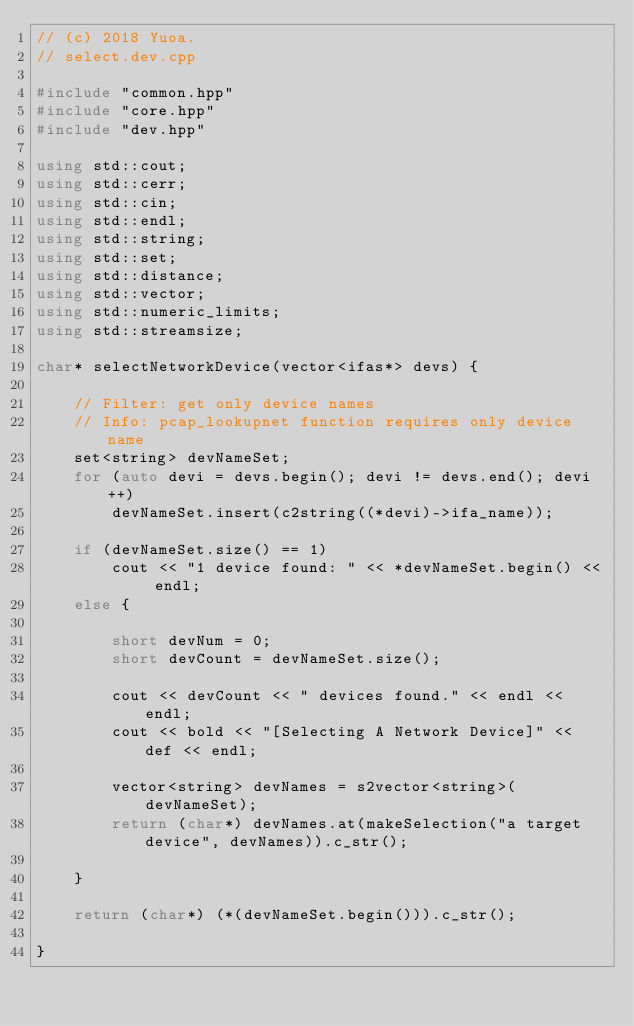<code> <loc_0><loc_0><loc_500><loc_500><_C++_>// (c) 2018 Yuoa.
// select.dev.cpp

#include "common.hpp"
#include "core.hpp"
#include "dev.hpp"

using std::cout;
using std::cerr;
using std::cin;
using std::endl;
using std::string;
using std::set;
using std::distance;
using std::vector;
using std::numeric_limits;
using std::streamsize;

char* selectNetworkDevice(vector<ifas*> devs) {

    // Filter: get only device names
    // Info: pcap_lookupnet function requires only device name
    set<string> devNameSet;
    for (auto devi = devs.begin(); devi != devs.end(); devi++)
        devNameSet.insert(c2string((*devi)->ifa_name));

    if (devNameSet.size() == 1)
        cout << "1 device found: " << *devNameSet.begin() << endl;
    else {

        short devNum = 0;
        short devCount = devNameSet.size();

        cout << devCount << " devices found." << endl << endl;
        cout << bold << "[Selecting A Network Device]" << def << endl;

        vector<string> devNames = s2vector<string>(devNameSet);
        return (char*) devNames.at(makeSelection("a target device", devNames)).c_str();

    }

    return (char*) (*(devNameSet.begin())).c_str();

}
</code> 